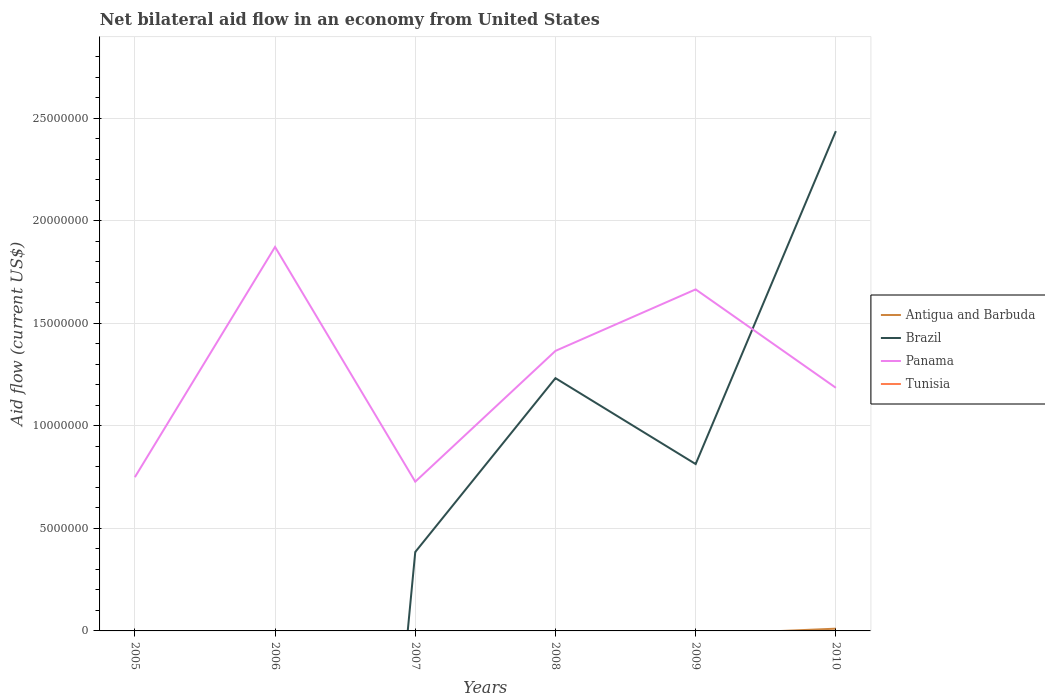Does the line corresponding to Panama intersect with the line corresponding to Tunisia?
Your response must be concise. No. Is the number of lines equal to the number of legend labels?
Provide a short and direct response. No. Across all years, what is the maximum net bilateral aid flow in Panama?
Your response must be concise. 7.28e+06. What is the total net bilateral aid flow in Brazil in the graph?
Offer a very short reply. -4.29e+06. What is the difference between the highest and the second highest net bilateral aid flow in Brazil?
Offer a terse response. 2.44e+07. What is the difference between the highest and the lowest net bilateral aid flow in Brazil?
Offer a very short reply. 3. Is the net bilateral aid flow in Antigua and Barbuda strictly greater than the net bilateral aid flow in Brazil over the years?
Offer a very short reply. No. How many lines are there?
Offer a very short reply. 3. How many years are there in the graph?
Provide a succinct answer. 6. What is the difference between two consecutive major ticks on the Y-axis?
Your response must be concise. 5.00e+06. Are the values on the major ticks of Y-axis written in scientific E-notation?
Offer a very short reply. No. Does the graph contain any zero values?
Your answer should be very brief. Yes. What is the title of the graph?
Make the answer very short. Net bilateral aid flow in an economy from United States. Does "High income: nonOECD" appear as one of the legend labels in the graph?
Make the answer very short. No. What is the label or title of the Y-axis?
Make the answer very short. Aid flow (current US$). What is the Aid flow (current US$) in Antigua and Barbuda in 2005?
Provide a succinct answer. 0. What is the Aid flow (current US$) in Panama in 2005?
Offer a very short reply. 7.50e+06. What is the Aid flow (current US$) in Antigua and Barbuda in 2006?
Your answer should be very brief. 0. What is the Aid flow (current US$) in Brazil in 2006?
Give a very brief answer. 0. What is the Aid flow (current US$) of Panama in 2006?
Provide a succinct answer. 1.87e+07. What is the Aid flow (current US$) of Antigua and Barbuda in 2007?
Provide a short and direct response. 0. What is the Aid flow (current US$) in Brazil in 2007?
Your response must be concise. 3.85e+06. What is the Aid flow (current US$) in Panama in 2007?
Offer a terse response. 7.28e+06. What is the Aid flow (current US$) of Antigua and Barbuda in 2008?
Your response must be concise. 0. What is the Aid flow (current US$) in Brazil in 2008?
Offer a terse response. 1.23e+07. What is the Aid flow (current US$) of Panama in 2008?
Keep it short and to the point. 1.37e+07. What is the Aid flow (current US$) of Antigua and Barbuda in 2009?
Make the answer very short. 0. What is the Aid flow (current US$) in Brazil in 2009?
Ensure brevity in your answer.  8.14e+06. What is the Aid flow (current US$) of Panama in 2009?
Offer a terse response. 1.67e+07. What is the Aid flow (current US$) of Antigua and Barbuda in 2010?
Give a very brief answer. 1.10e+05. What is the Aid flow (current US$) of Brazil in 2010?
Offer a terse response. 2.44e+07. What is the Aid flow (current US$) in Panama in 2010?
Your answer should be very brief. 1.19e+07. What is the Aid flow (current US$) in Tunisia in 2010?
Your answer should be very brief. 0. Across all years, what is the maximum Aid flow (current US$) of Brazil?
Your answer should be very brief. 2.44e+07. Across all years, what is the maximum Aid flow (current US$) of Panama?
Offer a terse response. 1.87e+07. Across all years, what is the minimum Aid flow (current US$) in Antigua and Barbuda?
Provide a short and direct response. 0. Across all years, what is the minimum Aid flow (current US$) in Brazil?
Give a very brief answer. 0. Across all years, what is the minimum Aid flow (current US$) of Panama?
Give a very brief answer. 7.28e+06. What is the total Aid flow (current US$) of Brazil in the graph?
Your response must be concise. 4.87e+07. What is the total Aid flow (current US$) in Panama in the graph?
Your answer should be compact. 7.57e+07. What is the total Aid flow (current US$) of Tunisia in the graph?
Your answer should be compact. 0. What is the difference between the Aid flow (current US$) of Panama in 2005 and that in 2006?
Keep it short and to the point. -1.12e+07. What is the difference between the Aid flow (current US$) in Panama in 2005 and that in 2007?
Provide a succinct answer. 2.20e+05. What is the difference between the Aid flow (current US$) of Panama in 2005 and that in 2008?
Your response must be concise. -6.16e+06. What is the difference between the Aid flow (current US$) of Panama in 2005 and that in 2009?
Offer a terse response. -9.16e+06. What is the difference between the Aid flow (current US$) in Panama in 2005 and that in 2010?
Your response must be concise. -4.36e+06. What is the difference between the Aid flow (current US$) of Panama in 2006 and that in 2007?
Ensure brevity in your answer.  1.14e+07. What is the difference between the Aid flow (current US$) in Panama in 2006 and that in 2008?
Your answer should be compact. 5.07e+06. What is the difference between the Aid flow (current US$) in Panama in 2006 and that in 2009?
Give a very brief answer. 2.07e+06. What is the difference between the Aid flow (current US$) of Panama in 2006 and that in 2010?
Give a very brief answer. 6.87e+06. What is the difference between the Aid flow (current US$) of Brazil in 2007 and that in 2008?
Make the answer very short. -8.48e+06. What is the difference between the Aid flow (current US$) of Panama in 2007 and that in 2008?
Offer a very short reply. -6.38e+06. What is the difference between the Aid flow (current US$) of Brazil in 2007 and that in 2009?
Your answer should be very brief. -4.29e+06. What is the difference between the Aid flow (current US$) in Panama in 2007 and that in 2009?
Ensure brevity in your answer.  -9.38e+06. What is the difference between the Aid flow (current US$) of Brazil in 2007 and that in 2010?
Provide a succinct answer. -2.05e+07. What is the difference between the Aid flow (current US$) in Panama in 2007 and that in 2010?
Your response must be concise. -4.58e+06. What is the difference between the Aid flow (current US$) of Brazil in 2008 and that in 2009?
Offer a very short reply. 4.19e+06. What is the difference between the Aid flow (current US$) of Panama in 2008 and that in 2009?
Provide a succinct answer. -3.00e+06. What is the difference between the Aid flow (current US$) in Brazil in 2008 and that in 2010?
Offer a very short reply. -1.20e+07. What is the difference between the Aid flow (current US$) of Panama in 2008 and that in 2010?
Your answer should be very brief. 1.80e+06. What is the difference between the Aid flow (current US$) in Brazil in 2009 and that in 2010?
Your response must be concise. -1.62e+07. What is the difference between the Aid flow (current US$) in Panama in 2009 and that in 2010?
Keep it short and to the point. 4.80e+06. What is the difference between the Aid flow (current US$) of Brazil in 2007 and the Aid flow (current US$) of Panama in 2008?
Offer a very short reply. -9.81e+06. What is the difference between the Aid flow (current US$) of Brazil in 2007 and the Aid flow (current US$) of Panama in 2009?
Ensure brevity in your answer.  -1.28e+07. What is the difference between the Aid flow (current US$) of Brazil in 2007 and the Aid flow (current US$) of Panama in 2010?
Ensure brevity in your answer.  -8.01e+06. What is the difference between the Aid flow (current US$) of Brazil in 2008 and the Aid flow (current US$) of Panama in 2009?
Make the answer very short. -4.33e+06. What is the difference between the Aid flow (current US$) in Brazil in 2009 and the Aid flow (current US$) in Panama in 2010?
Offer a terse response. -3.72e+06. What is the average Aid flow (current US$) in Antigua and Barbuda per year?
Offer a very short reply. 1.83e+04. What is the average Aid flow (current US$) of Brazil per year?
Your answer should be compact. 8.12e+06. What is the average Aid flow (current US$) of Panama per year?
Keep it short and to the point. 1.26e+07. What is the average Aid flow (current US$) of Tunisia per year?
Your answer should be compact. 0. In the year 2007, what is the difference between the Aid flow (current US$) of Brazil and Aid flow (current US$) of Panama?
Make the answer very short. -3.43e+06. In the year 2008, what is the difference between the Aid flow (current US$) of Brazil and Aid flow (current US$) of Panama?
Keep it short and to the point. -1.33e+06. In the year 2009, what is the difference between the Aid flow (current US$) in Brazil and Aid flow (current US$) in Panama?
Your response must be concise. -8.52e+06. In the year 2010, what is the difference between the Aid flow (current US$) of Antigua and Barbuda and Aid flow (current US$) of Brazil?
Your answer should be very brief. -2.43e+07. In the year 2010, what is the difference between the Aid flow (current US$) of Antigua and Barbuda and Aid flow (current US$) of Panama?
Provide a short and direct response. -1.18e+07. In the year 2010, what is the difference between the Aid flow (current US$) in Brazil and Aid flow (current US$) in Panama?
Your answer should be very brief. 1.25e+07. What is the ratio of the Aid flow (current US$) in Panama in 2005 to that in 2006?
Ensure brevity in your answer.  0.4. What is the ratio of the Aid flow (current US$) in Panama in 2005 to that in 2007?
Give a very brief answer. 1.03. What is the ratio of the Aid flow (current US$) of Panama in 2005 to that in 2008?
Offer a very short reply. 0.55. What is the ratio of the Aid flow (current US$) in Panama in 2005 to that in 2009?
Your answer should be very brief. 0.45. What is the ratio of the Aid flow (current US$) of Panama in 2005 to that in 2010?
Give a very brief answer. 0.63. What is the ratio of the Aid flow (current US$) of Panama in 2006 to that in 2007?
Your answer should be very brief. 2.57. What is the ratio of the Aid flow (current US$) in Panama in 2006 to that in 2008?
Make the answer very short. 1.37. What is the ratio of the Aid flow (current US$) in Panama in 2006 to that in 2009?
Your response must be concise. 1.12. What is the ratio of the Aid flow (current US$) of Panama in 2006 to that in 2010?
Your answer should be very brief. 1.58. What is the ratio of the Aid flow (current US$) of Brazil in 2007 to that in 2008?
Provide a short and direct response. 0.31. What is the ratio of the Aid flow (current US$) in Panama in 2007 to that in 2008?
Offer a very short reply. 0.53. What is the ratio of the Aid flow (current US$) of Brazil in 2007 to that in 2009?
Your answer should be very brief. 0.47. What is the ratio of the Aid flow (current US$) of Panama in 2007 to that in 2009?
Ensure brevity in your answer.  0.44. What is the ratio of the Aid flow (current US$) of Brazil in 2007 to that in 2010?
Your answer should be very brief. 0.16. What is the ratio of the Aid flow (current US$) in Panama in 2007 to that in 2010?
Give a very brief answer. 0.61. What is the ratio of the Aid flow (current US$) of Brazil in 2008 to that in 2009?
Provide a short and direct response. 1.51. What is the ratio of the Aid flow (current US$) in Panama in 2008 to that in 2009?
Your answer should be very brief. 0.82. What is the ratio of the Aid flow (current US$) of Brazil in 2008 to that in 2010?
Provide a short and direct response. 0.51. What is the ratio of the Aid flow (current US$) in Panama in 2008 to that in 2010?
Give a very brief answer. 1.15. What is the ratio of the Aid flow (current US$) in Brazil in 2009 to that in 2010?
Make the answer very short. 0.33. What is the ratio of the Aid flow (current US$) of Panama in 2009 to that in 2010?
Provide a short and direct response. 1.4. What is the difference between the highest and the second highest Aid flow (current US$) in Brazil?
Provide a short and direct response. 1.20e+07. What is the difference between the highest and the second highest Aid flow (current US$) of Panama?
Offer a terse response. 2.07e+06. What is the difference between the highest and the lowest Aid flow (current US$) of Antigua and Barbuda?
Make the answer very short. 1.10e+05. What is the difference between the highest and the lowest Aid flow (current US$) of Brazil?
Ensure brevity in your answer.  2.44e+07. What is the difference between the highest and the lowest Aid flow (current US$) in Panama?
Provide a short and direct response. 1.14e+07. 